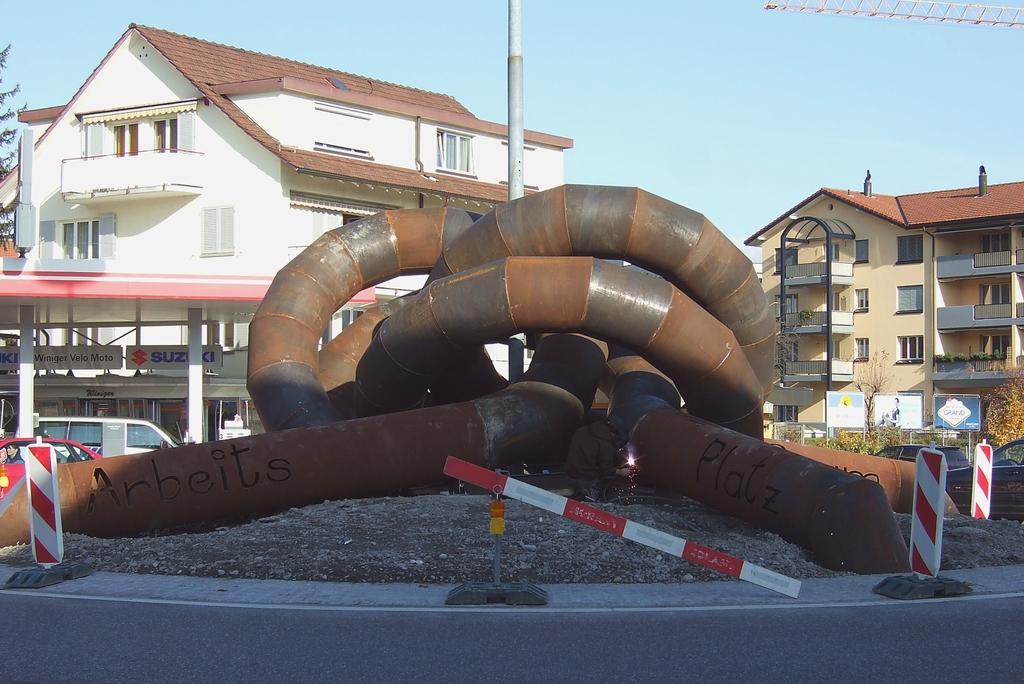Please provide a concise description of this image. In this image, we can see pipes, banners, rod. At the bottom, there is a road. Background we can see few vehicles, plants, buildings, pillars, walls, windows, trees, hoardings, pole and sky. Right side top corner, we can see some object. 